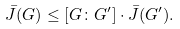Convert formula to latex. <formula><loc_0><loc_0><loc_500><loc_500>\bar { J } ( G ) \leq [ G \colon G ^ { \prime } ] \cdot \bar { J } ( G ^ { \prime } ) .</formula> 